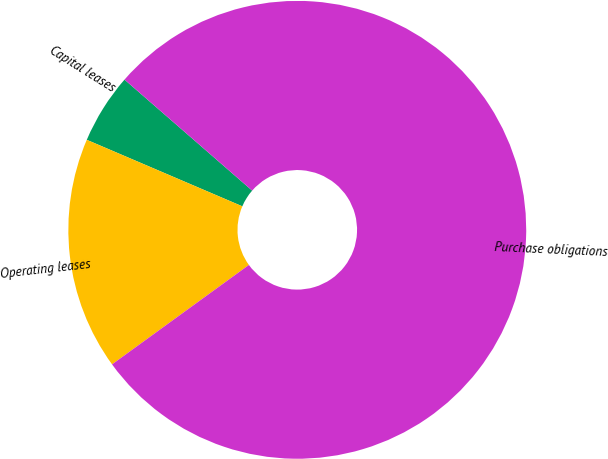Convert chart to OTSL. <chart><loc_0><loc_0><loc_500><loc_500><pie_chart><fcel>Capital leases<fcel>Operating leases<fcel>Purchase obligations<nl><fcel>4.96%<fcel>16.43%<fcel>78.61%<nl></chart> 